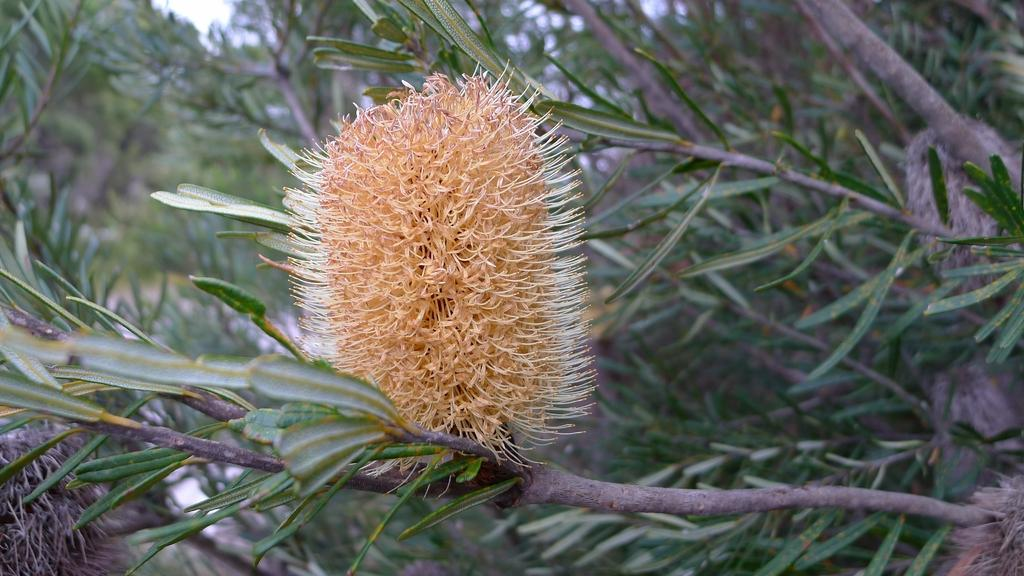What is the main subject of the image? The main subject of the image is a flower. What other parts of the plant can be seen in the image? There are leaves and stems visible in the image. What color is the background of the image? The background of the image is green. What type of magic is being performed with the flower in the image? There is no magic or any indication of a magical performance in the image; it simply features a flower, leaves, and stems. 